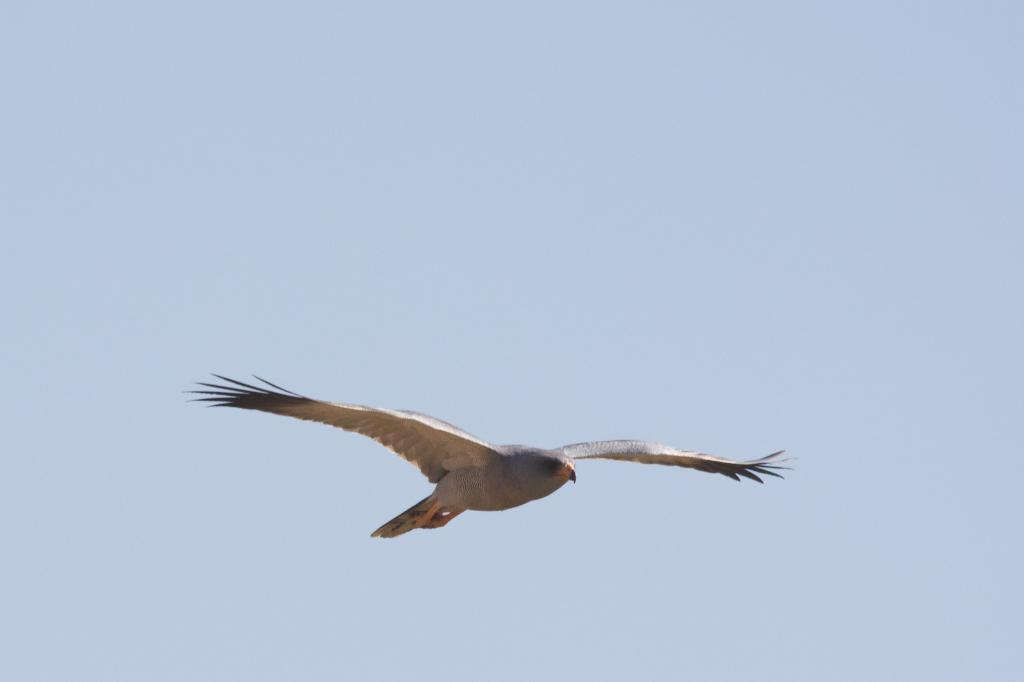What animal is featured in the image? There is an eagle in the image. What is the eagle doing in the image? The eagle is flying in the image. What can be seen in the background of the image? The background of the image appears to be the sky. What is the color of the sky in the image? The sky is light blue in color. Can you tell me how many doors are visible in the image? There are no doors present in the image; it features an eagle flying in the sky. 